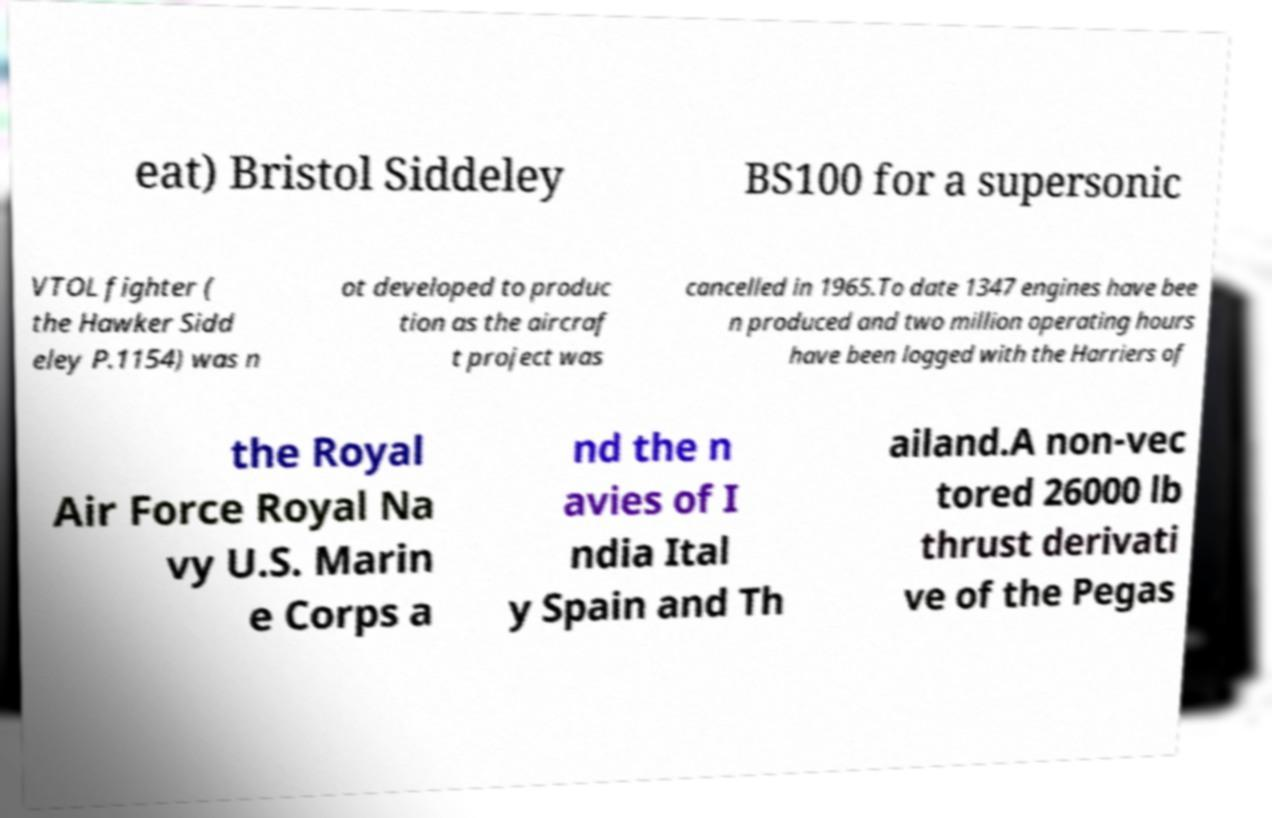What messages or text are displayed in this image? I need them in a readable, typed format. eat) Bristol Siddeley BS100 for a supersonic VTOL fighter ( the Hawker Sidd eley P.1154) was n ot developed to produc tion as the aircraf t project was cancelled in 1965.To date 1347 engines have bee n produced and two million operating hours have been logged with the Harriers of the Royal Air Force Royal Na vy U.S. Marin e Corps a nd the n avies of I ndia Ital y Spain and Th ailand.A non-vec tored 26000 lb thrust derivati ve of the Pegas 